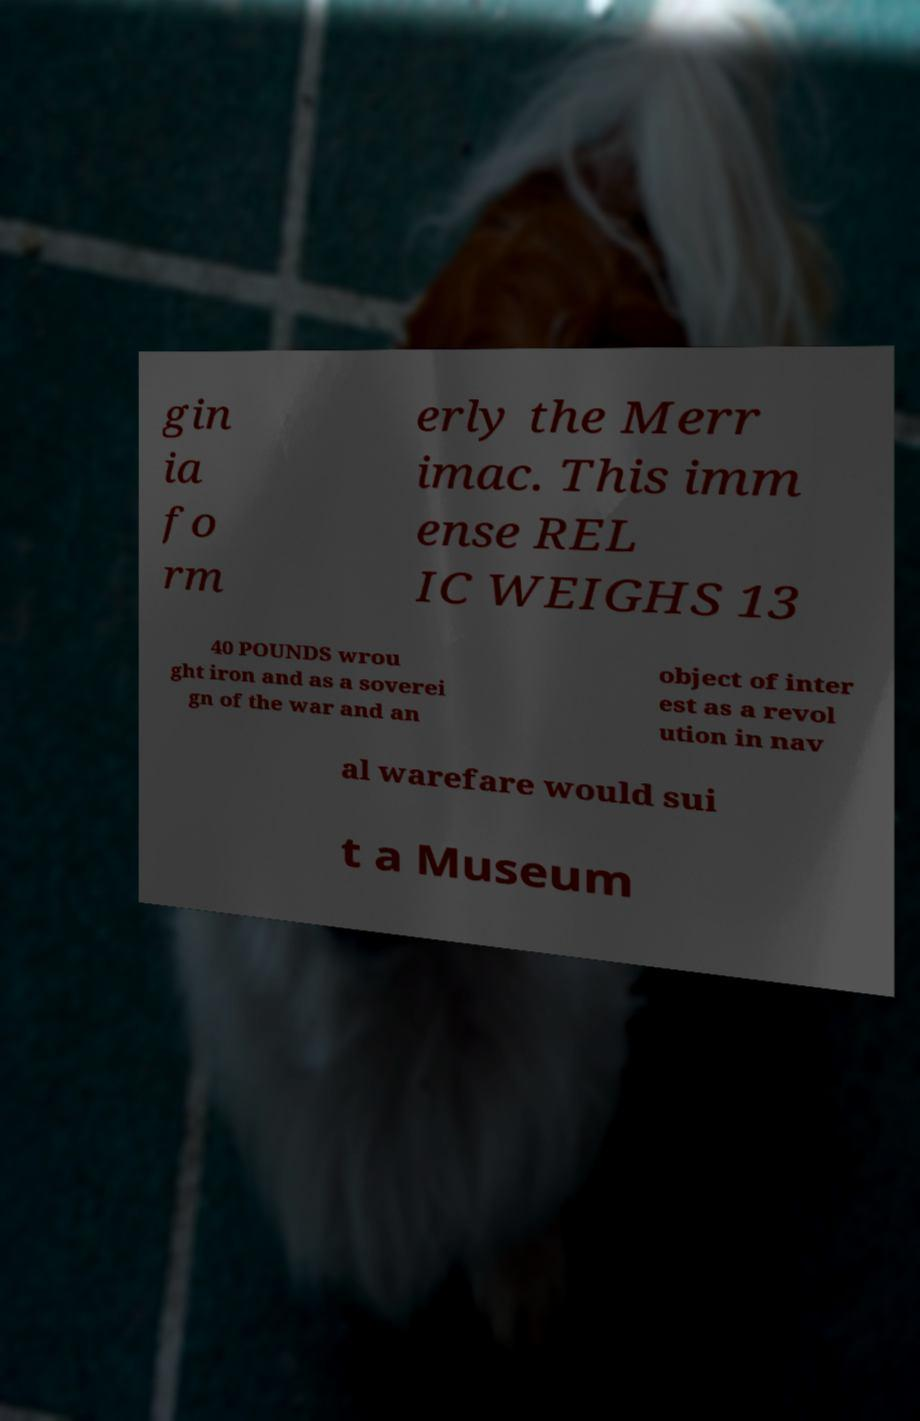What messages or text are displayed in this image? I need them in a readable, typed format. gin ia fo rm erly the Merr imac. This imm ense REL IC WEIGHS 13 40 POUNDS wrou ght iron and as a soverei gn of the war and an object of inter est as a revol ution in nav al warefare would sui t a Museum 